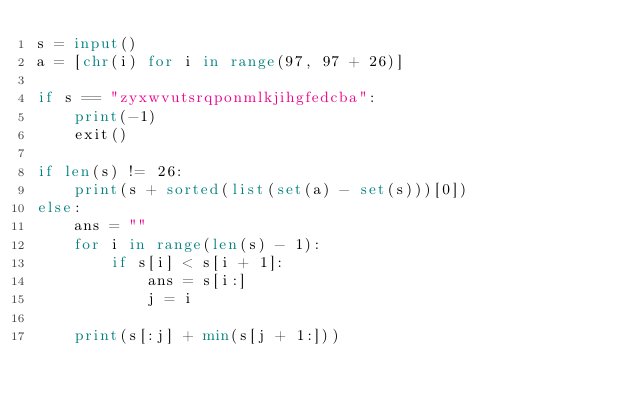Convert code to text. <code><loc_0><loc_0><loc_500><loc_500><_Python_>s = input()
a = [chr(i) for i in range(97, 97 + 26)]

if s == "zyxwvutsrqponmlkjihgfedcba":
    print(-1)
    exit()

if len(s) != 26:
    print(s + sorted(list(set(a) - set(s)))[0])
else:
    ans = ""
    for i in range(len(s) - 1):
        if s[i] < s[i + 1]:
            ans = s[i:]
            j = i

    print(s[:j] + min(s[j + 1:]))</code> 